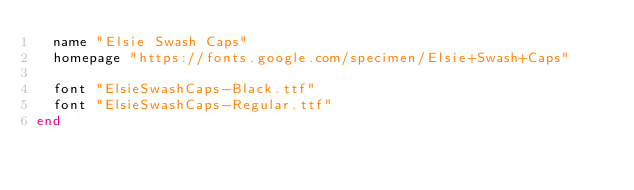<code> <loc_0><loc_0><loc_500><loc_500><_Ruby_>  name "Elsie Swash Caps"
  homepage "https://fonts.google.com/specimen/Elsie+Swash+Caps"

  font "ElsieSwashCaps-Black.ttf"
  font "ElsieSwashCaps-Regular.ttf"
end
</code> 